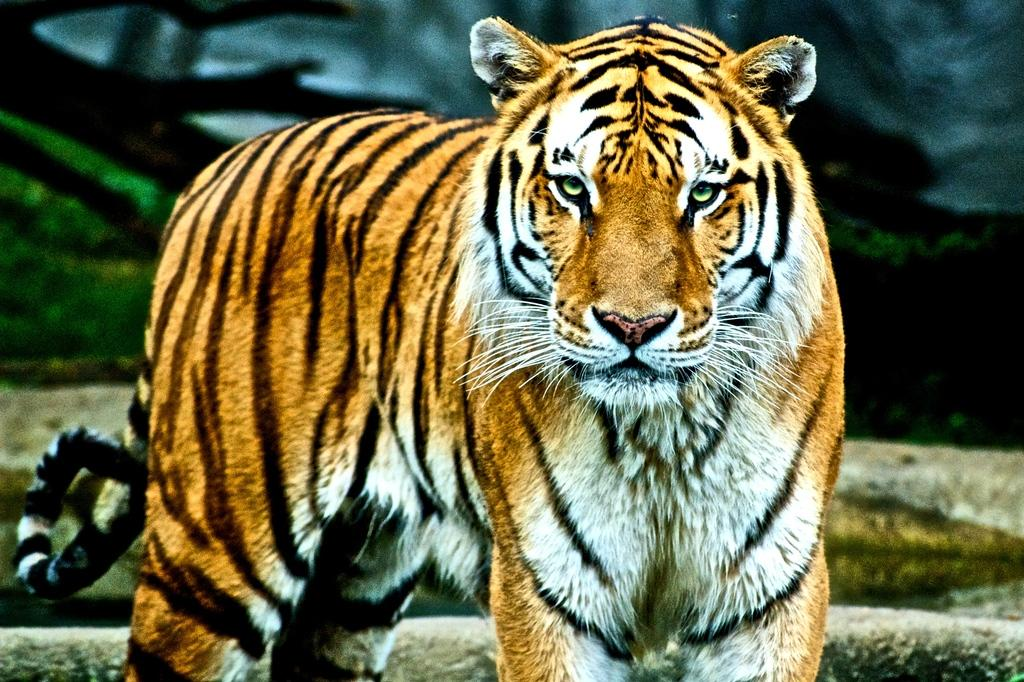What animal is the main subject of the image? There is a tiger in the image. What is the tiger doing in the image? The tiger is standing. What color pattern does the tiger have? The tiger has a color pattern of white, yellow, and black. Can you describe the quality of the image? The image may be slightly blurry in the background. What is the tiger's brain size compared to its chin in the image? There is no information about the tiger's brain size or chin in the image, as it only shows the tiger standing with a color pattern of white, yellow, and black. 